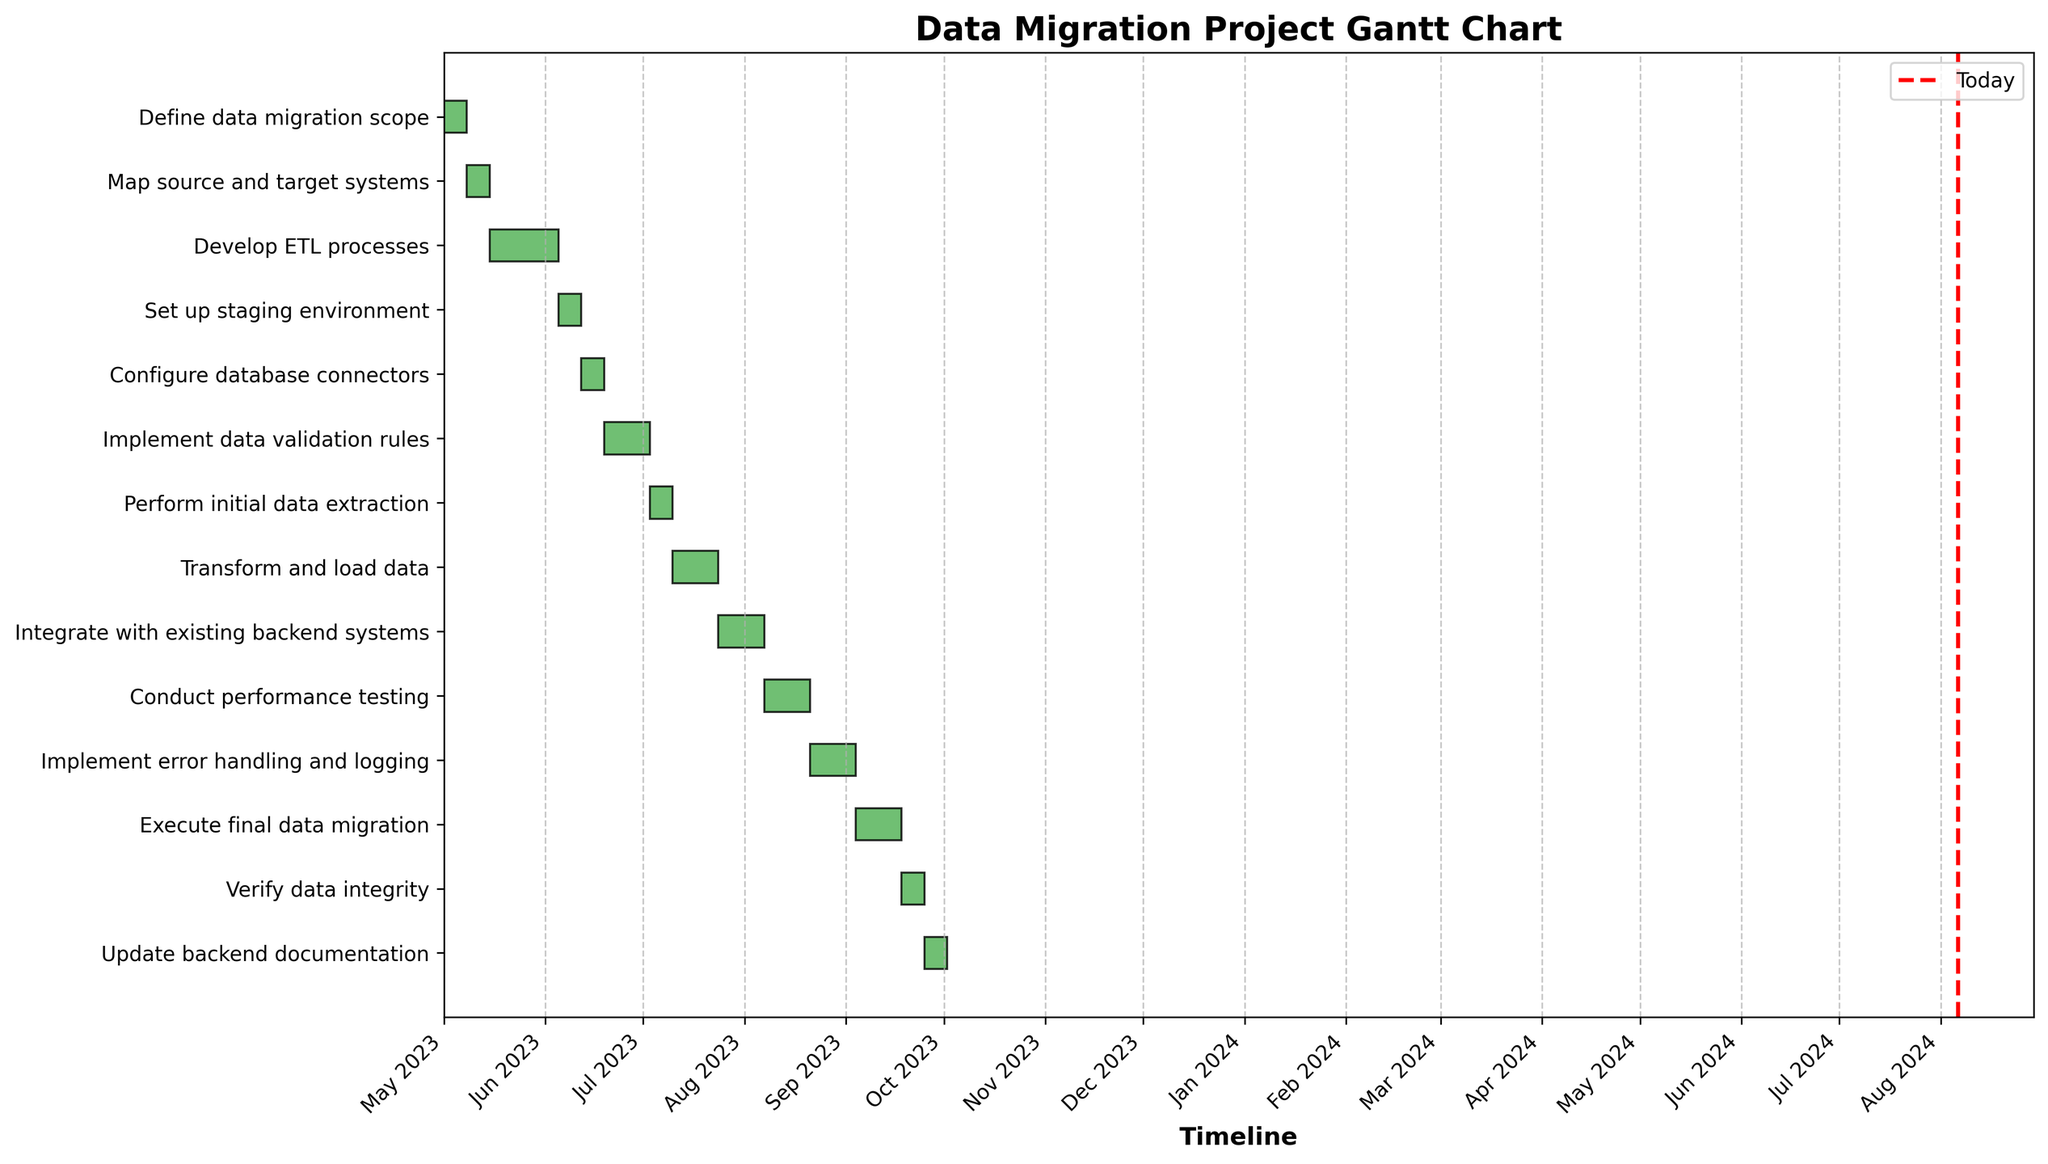What is the title of the chart? The title of the chart is usually located at the top of the figure and describes the content of the chart for the reader. In this case, the title of the chart displayed is "Data Migration Project Gantt Chart".
Answer: Data Migration Project Gantt Chart How many tasks are displayed in the chart? By counting the distinct number of bars on the y-axis, we can determine the number of tasks displayed. Each bar represents one task.
Answer: 14 What task runs from July 24 to August 6? By looking at the leftmost and rightmost edges of the bars that span from July 24 to August 6, we can identify the corresponding task label on the y-axis.
Answer: Integrate with existing backend systems Which task has the shortest duration? The shortest bar along the x-axis represents the shortest duration. By checking the task labels, we can identify the task with the shortest duration.
Answer: Define data migration scope How many tasks have a duration of 14 days? By visually inspecting bars that span 14 days on the timeline and counting them, we can determine the number of such tasks.
Answer: 6 What is the start date of 'Develop ETL processes'? By locating the bar labeled 'Develop ETL processes' along the y-axis and observing its starting point on the x-axis, we can find the start date.
Answer: May 15 Which task's duration includes the current date line (Today)? Look for the red dashed vertical line indicating today's date and identify the task bars it intersects.
Answer: Verify data integrity How much longer does the 'Conduct performance testing' task take compared to the 'Configure database connectors' task? Find the durations of both tasks by observing the length of their bars, then compute the difference between them. 'Conduct performance testing' takes 14 days and 'Configure database connectors' takes 7 days. Therefore, the difference is 14 - 7 = 7 days.
Answer: 7 days Which tasks need to finish before 'Integrate with existing backend systems' can start? Locate 'Integrate with existing backend systems' on the y-axis and look at all bars that end before its start date. These tasks are prerequisites.
Answer: Transform and load data How many tasks are scheduled to be completed by the end of August? Look at tasks with end dates no later than August 31 and count them.
Answer: 10 